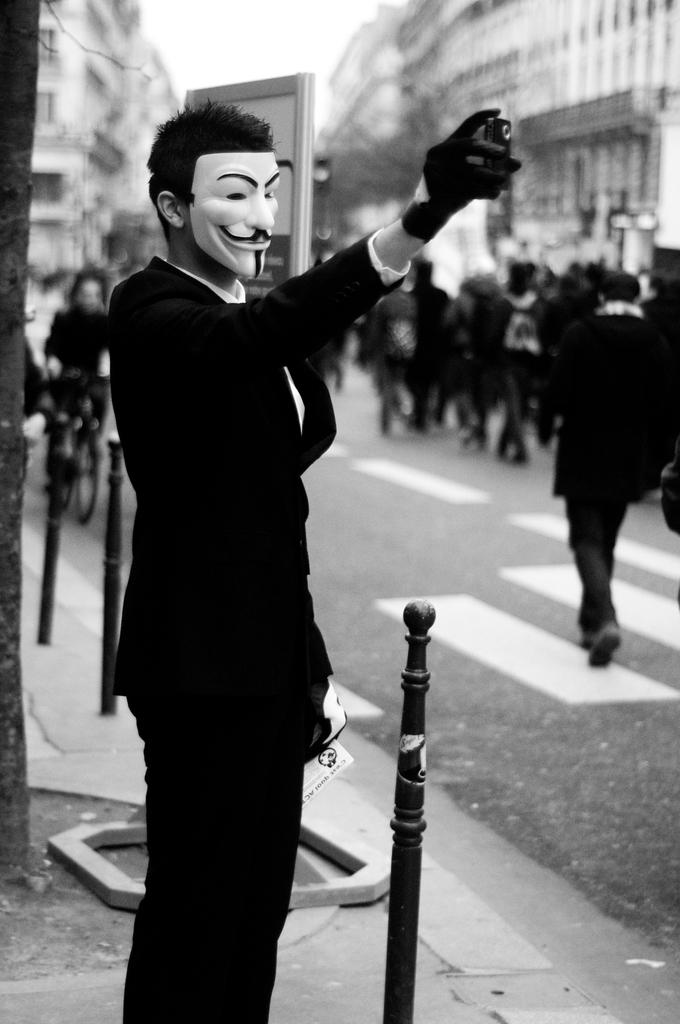What is the color scheme of the image? The image is black and white. Can you describe the person in the image? There is a person standing in the image, and they are wearing a mask. What can be observed about the background of the image? The background of the image is blurred. What type of pie is being served during the spring week in the image? There is no pie or reference to a spring week in the image; it is a black and white image of a person wearing a mask with a blurred background. 